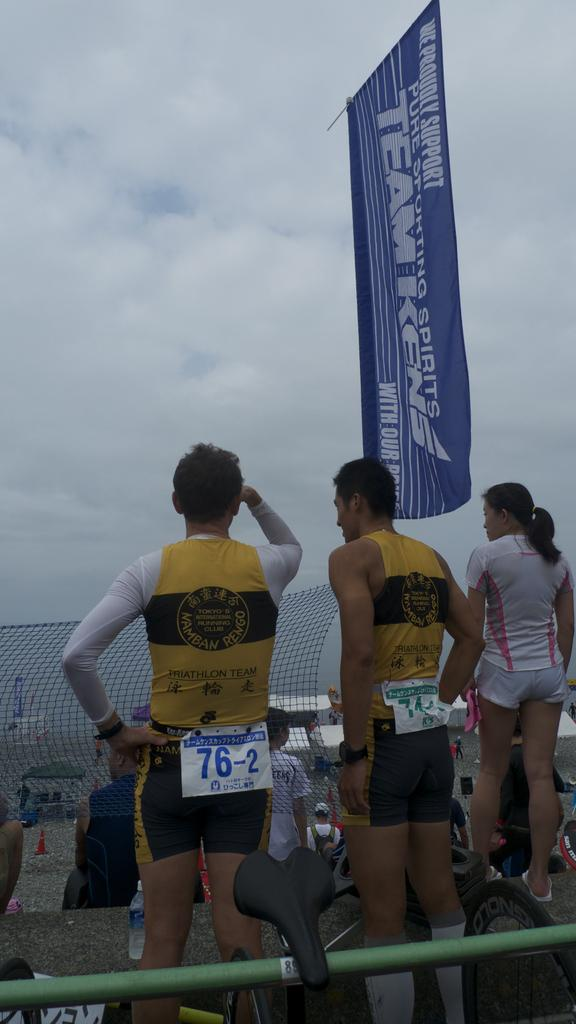What can be observed about the attire of the persons in the image? There are persons in different color dresses in the image. What are the persons doing in the image? The persons are standing. What is in front of the persons in the image? There is a net and a flag in front of the persons. What is visible in the sky in the image? There are clouds in the sky in the image. What is the wealth status of the persons in the image? The provided facts do not give any information about the wealth status of the persons in the image. What time of day is it in the image? The provided facts do not give any information about the time of day in the image. 